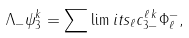<formula> <loc_0><loc_0><loc_500><loc_500>\Lambda _ { - } \psi _ { 3 } ^ { k } = \sum \lim i t s _ { \ell } { c _ { 3 - } ^ { \ell \, k } \Phi _ { \ell } ^ { - } } ,</formula> 